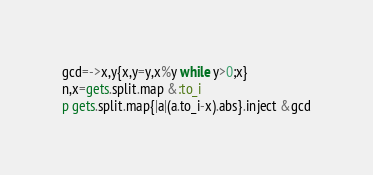Convert code to text. <code><loc_0><loc_0><loc_500><loc_500><_Ruby_>gcd=->x,y{x,y=y,x%y while y>0;x}
n,x=gets.split.map &:to_i
p gets.split.map{|a|(a.to_i-x).abs}.inject &gcd</code> 